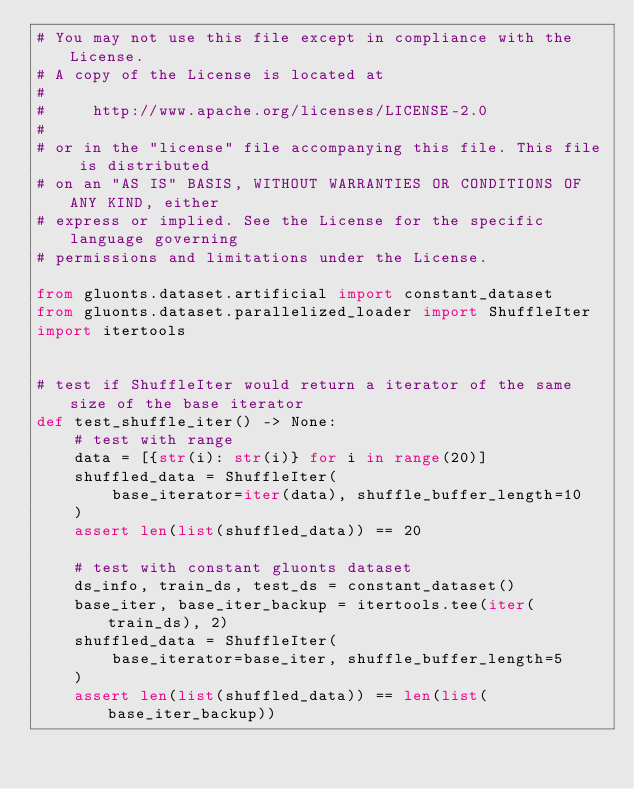<code> <loc_0><loc_0><loc_500><loc_500><_Python_># You may not use this file except in compliance with the License.
# A copy of the License is located at
#
#     http://www.apache.org/licenses/LICENSE-2.0
#
# or in the "license" file accompanying this file. This file is distributed
# on an "AS IS" BASIS, WITHOUT WARRANTIES OR CONDITIONS OF ANY KIND, either
# express or implied. See the License for the specific language governing
# permissions and limitations under the License.

from gluonts.dataset.artificial import constant_dataset
from gluonts.dataset.parallelized_loader import ShuffleIter
import itertools


# test if ShuffleIter would return a iterator of the same size of the base iterator
def test_shuffle_iter() -> None:
    # test with range
    data = [{str(i): str(i)} for i in range(20)]
    shuffled_data = ShuffleIter(
        base_iterator=iter(data), shuffle_buffer_length=10
    )
    assert len(list(shuffled_data)) == 20

    # test with constant gluonts dataset
    ds_info, train_ds, test_ds = constant_dataset()
    base_iter, base_iter_backup = itertools.tee(iter(train_ds), 2)
    shuffled_data = ShuffleIter(
        base_iterator=base_iter, shuffle_buffer_length=5
    )
    assert len(list(shuffled_data)) == len(list(base_iter_backup))
</code> 